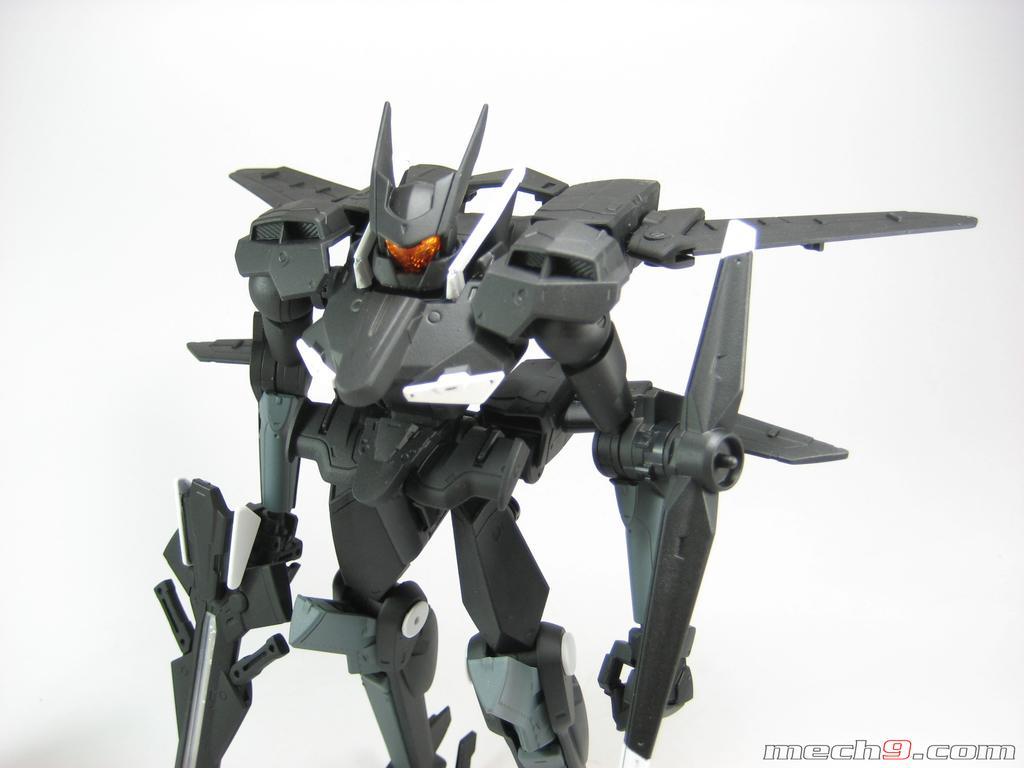Describe this image in one or two sentences. In this picture we can see a toy robot and in the background it is white color. 